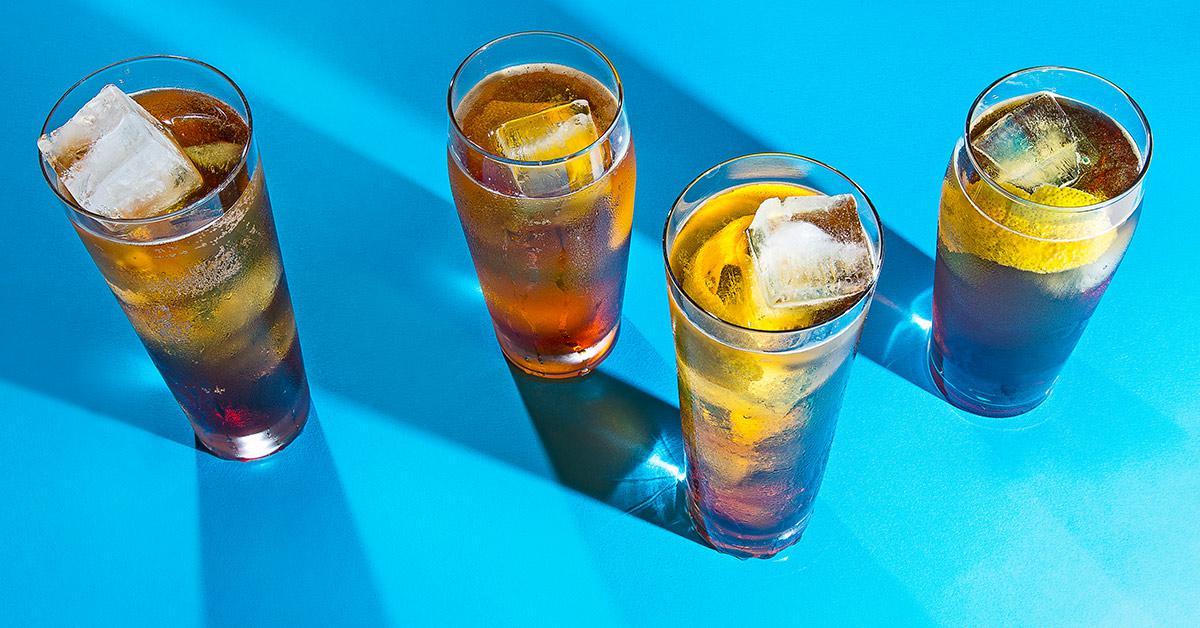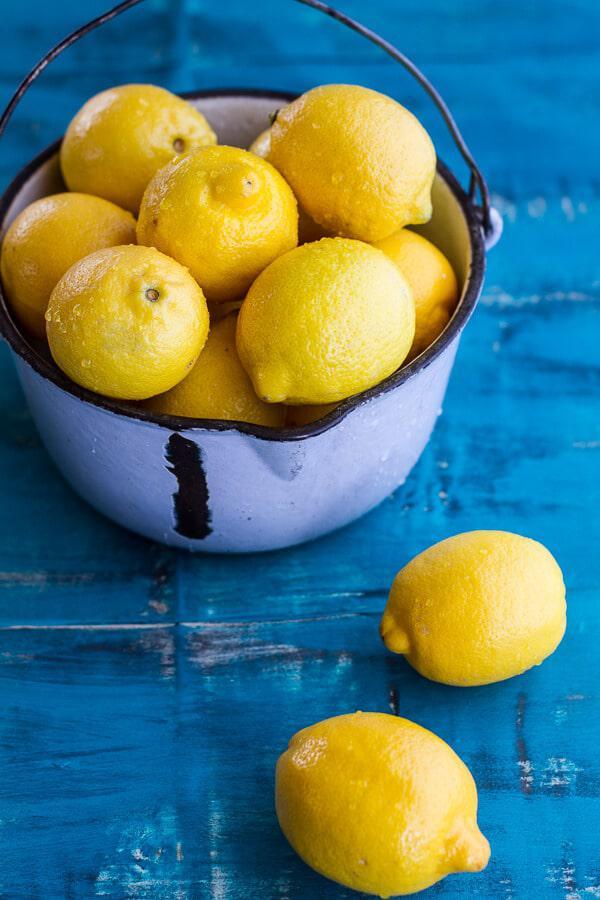The first image is the image on the left, the second image is the image on the right. Considering the images on both sides, is "There are no more than 5 full drink glasses." valid? Answer yes or no. Yes. The first image is the image on the left, the second image is the image on the right. Considering the images on both sides, is "Dessert drinks in one image are pink in tall glasses, and in the other are pink in short glasses." valid? Answer yes or no. No. 